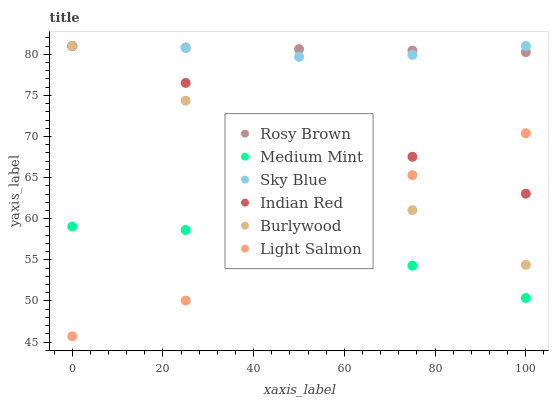Does Medium Mint have the minimum area under the curve?
Answer yes or no. Yes. Does Rosy Brown have the maximum area under the curve?
Answer yes or no. Yes. Does Light Salmon have the minimum area under the curve?
Answer yes or no. No. Does Light Salmon have the maximum area under the curve?
Answer yes or no. No. Is Burlywood the smoothest?
Answer yes or no. Yes. Is Light Salmon the roughest?
Answer yes or no. Yes. Is Light Salmon the smoothest?
Answer yes or no. No. Is Burlywood the roughest?
Answer yes or no. No. Does Light Salmon have the lowest value?
Answer yes or no. Yes. Does Burlywood have the lowest value?
Answer yes or no. No. Does Sky Blue have the highest value?
Answer yes or no. Yes. Does Light Salmon have the highest value?
Answer yes or no. No. Is Medium Mint less than Rosy Brown?
Answer yes or no. Yes. Is Rosy Brown greater than Medium Mint?
Answer yes or no. Yes. Does Light Salmon intersect Burlywood?
Answer yes or no. Yes. Is Light Salmon less than Burlywood?
Answer yes or no. No. Is Light Salmon greater than Burlywood?
Answer yes or no. No. Does Medium Mint intersect Rosy Brown?
Answer yes or no. No. 